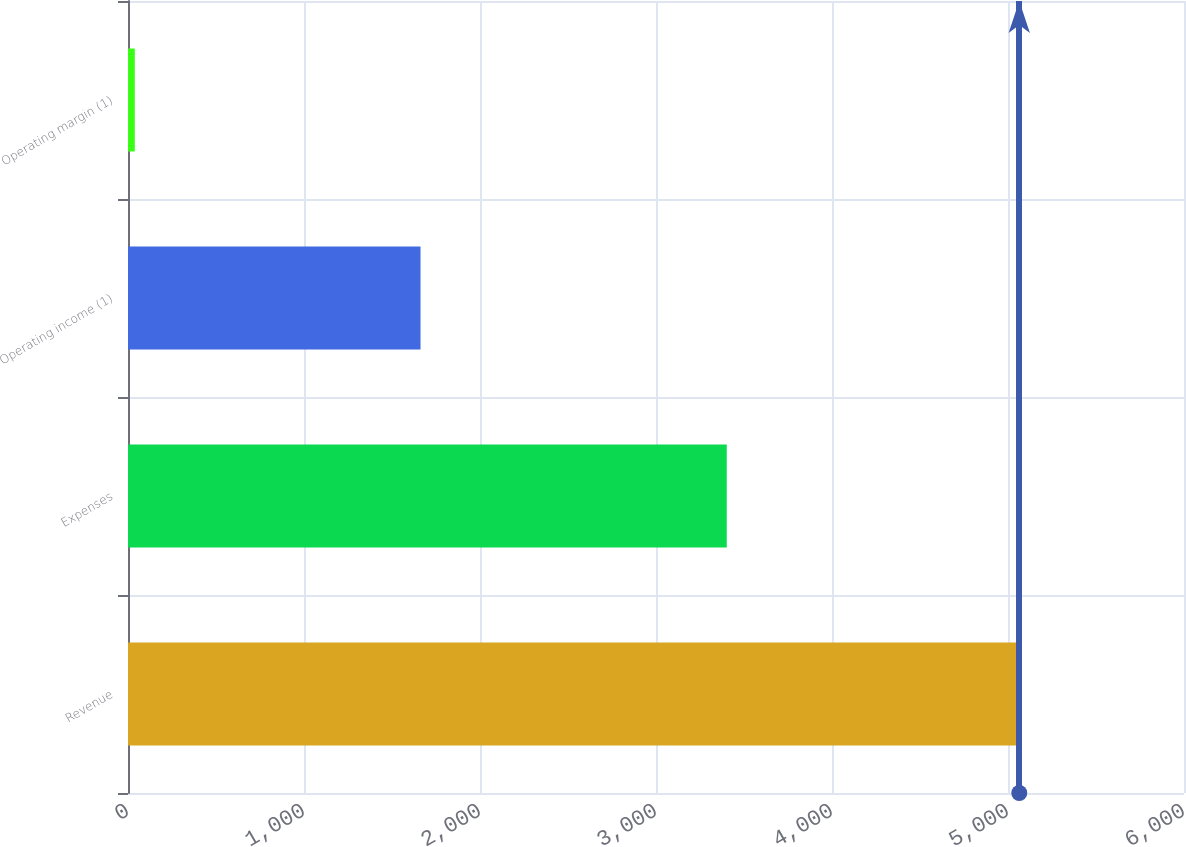Convert chart to OTSL. <chart><loc_0><loc_0><loc_500><loc_500><bar_chart><fcel>Revenue<fcel>Expenses<fcel>Operating income (1)<fcel>Operating margin (1)<nl><fcel>5064<fcel>3402<fcel>1662<fcel>38.7<nl></chart> 